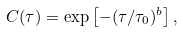Convert formula to latex. <formula><loc_0><loc_0><loc_500><loc_500>C ( \tau ) = \exp \left [ - ( \tau / \tau _ { 0 } ) ^ { b } \right ] ,</formula> 